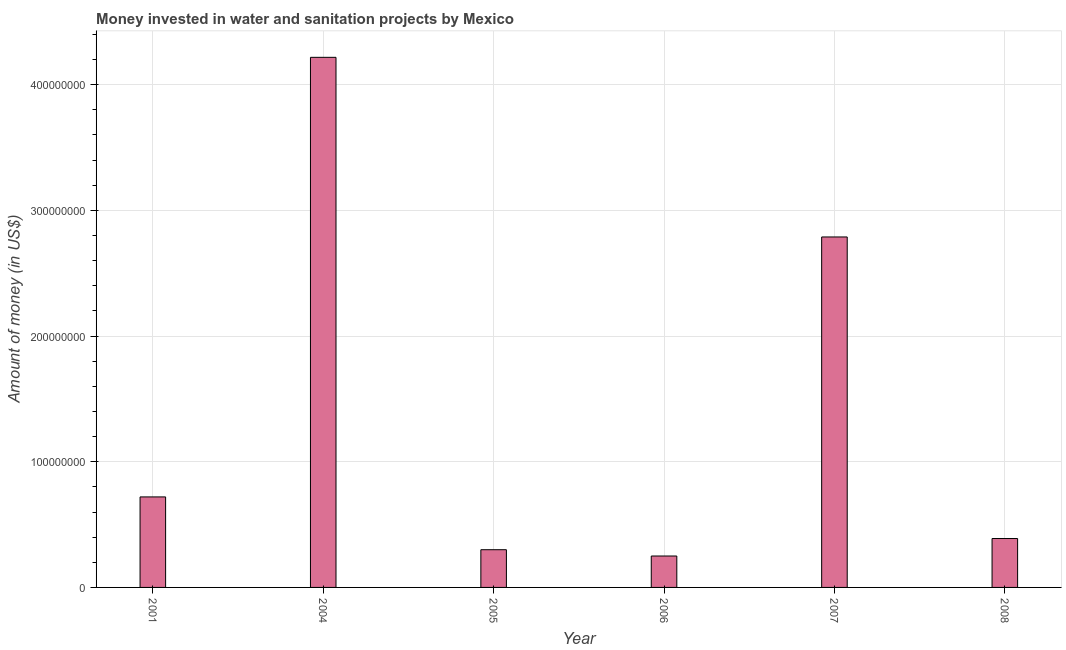Does the graph contain any zero values?
Make the answer very short. No. What is the title of the graph?
Offer a terse response. Money invested in water and sanitation projects by Mexico. What is the label or title of the X-axis?
Make the answer very short. Year. What is the label or title of the Y-axis?
Make the answer very short. Amount of money (in US$). What is the investment in 2001?
Give a very brief answer. 7.20e+07. Across all years, what is the maximum investment?
Provide a succinct answer. 4.22e+08. Across all years, what is the minimum investment?
Provide a short and direct response. 2.50e+07. In which year was the investment minimum?
Your response must be concise. 2006. What is the sum of the investment?
Keep it short and to the point. 8.66e+08. What is the difference between the investment in 2001 and 2004?
Offer a terse response. -3.50e+08. What is the average investment per year?
Your response must be concise. 1.44e+08. What is the median investment?
Your answer should be very brief. 5.54e+07. Do a majority of the years between 2008 and 2005 (inclusive) have investment greater than 60000000 US$?
Your answer should be very brief. Yes. What is the ratio of the investment in 2001 to that in 2004?
Your answer should be compact. 0.17. Is the investment in 2004 less than that in 2008?
Give a very brief answer. No. What is the difference between the highest and the second highest investment?
Make the answer very short. 1.43e+08. Is the sum of the investment in 2001 and 2006 greater than the maximum investment across all years?
Your answer should be very brief. No. What is the difference between the highest and the lowest investment?
Your answer should be compact. 3.97e+08. In how many years, is the investment greater than the average investment taken over all years?
Keep it short and to the point. 2. Are all the bars in the graph horizontal?
Offer a terse response. No. What is the Amount of money (in US$) in 2001?
Your answer should be very brief. 7.20e+07. What is the Amount of money (in US$) of 2004?
Make the answer very short. 4.22e+08. What is the Amount of money (in US$) of 2005?
Your answer should be compact. 3.00e+07. What is the Amount of money (in US$) of 2006?
Your answer should be compact. 2.50e+07. What is the Amount of money (in US$) of 2007?
Ensure brevity in your answer.  2.79e+08. What is the Amount of money (in US$) in 2008?
Provide a short and direct response. 3.89e+07. What is the difference between the Amount of money (in US$) in 2001 and 2004?
Offer a terse response. -3.50e+08. What is the difference between the Amount of money (in US$) in 2001 and 2005?
Provide a succinct answer. 4.20e+07. What is the difference between the Amount of money (in US$) in 2001 and 2006?
Keep it short and to the point. 4.70e+07. What is the difference between the Amount of money (in US$) in 2001 and 2007?
Your response must be concise. -2.07e+08. What is the difference between the Amount of money (in US$) in 2001 and 2008?
Your answer should be compact. 3.31e+07. What is the difference between the Amount of money (in US$) in 2004 and 2005?
Offer a terse response. 3.92e+08. What is the difference between the Amount of money (in US$) in 2004 and 2006?
Provide a short and direct response. 3.97e+08. What is the difference between the Amount of money (in US$) in 2004 and 2007?
Offer a very short reply. 1.43e+08. What is the difference between the Amount of money (in US$) in 2004 and 2008?
Provide a short and direct response. 3.83e+08. What is the difference between the Amount of money (in US$) in 2005 and 2006?
Offer a terse response. 5.00e+06. What is the difference between the Amount of money (in US$) in 2005 and 2007?
Ensure brevity in your answer.  -2.49e+08. What is the difference between the Amount of money (in US$) in 2005 and 2008?
Your response must be concise. -8.90e+06. What is the difference between the Amount of money (in US$) in 2006 and 2007?
Your answer should be compact. -2.54e+08. What is the difference between the Amount of money (in US$) in 2006 and 2008?
Your answer should be compact. -1.39e+07. What is the difference between the Amount of money (in US$) in 2007 and 2008?
Keep it short and to the point. 2.40e+08. What is the ratio of the Amount of money (in US$) in 2001 to that in 2004?
Provide a succinct answer. 0.17. What is the ratio of the Amount of money (in US$) in 2001 to that in 2005?
Ensure brevity in your answer.  2.4. What is the ratio of the Amount of money (in US$) in 2001 to that in 2006?
Offer a terse response. 2.88. What is the ratio of the Amount of money (in US$) in 2001 to that in 2007?
Offer a terse response. 0.26. What is the ratio of the Amount of money (in US$) in 2001 to that in 2008?
Keep it short and to the point. 1.85. What is the ratio of the Amount of money (in US$) in 2004 to that in 2005?
Provide a short and direct response. 14.06. What is the ratio of the Amount of money (in US$) in 2004 to that in 2006?
Offer a terse response. 16.87. What is the ratio of the Amount of money (in US$) in 2004 to that in 2007?
Provide a short and direct response. 1.51. What is the ratio of the Amount of money (in US$) in 2004 to that in 2008?
Your answer should be compact. 10.84. What is the ratio of the Amount of money (in US$) in 2005 to that in 2006?
Keep it short and to the point. 1.2. What is the ratio of the Amount of money (in US$) in 2005 to that in 2007?
Offer a very short reply. 0.11. What is the ratio of the Amount of money (in US$) in 2005 to that in 2008?
Offer a terse response. 0.77. What is the ratio of the Amount of money (in US$) in 2006 to that in 2007?
Offer a terse response. 0.09. What is the ratio of the Amount of money (in US$) in 2006 to that in 2008?
Your answer should be compact. 0.64. What is the ratio of the Amount of money (in US$) in 2007 to that in 2008?
Provide a short and direct response. 7.17. 